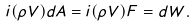Convert formula to latex. <formula><loc_0><loc_0><loc_500><loc_500>i ( \rho V ) d A = i ( \rho V ) F = d W .</formula> 